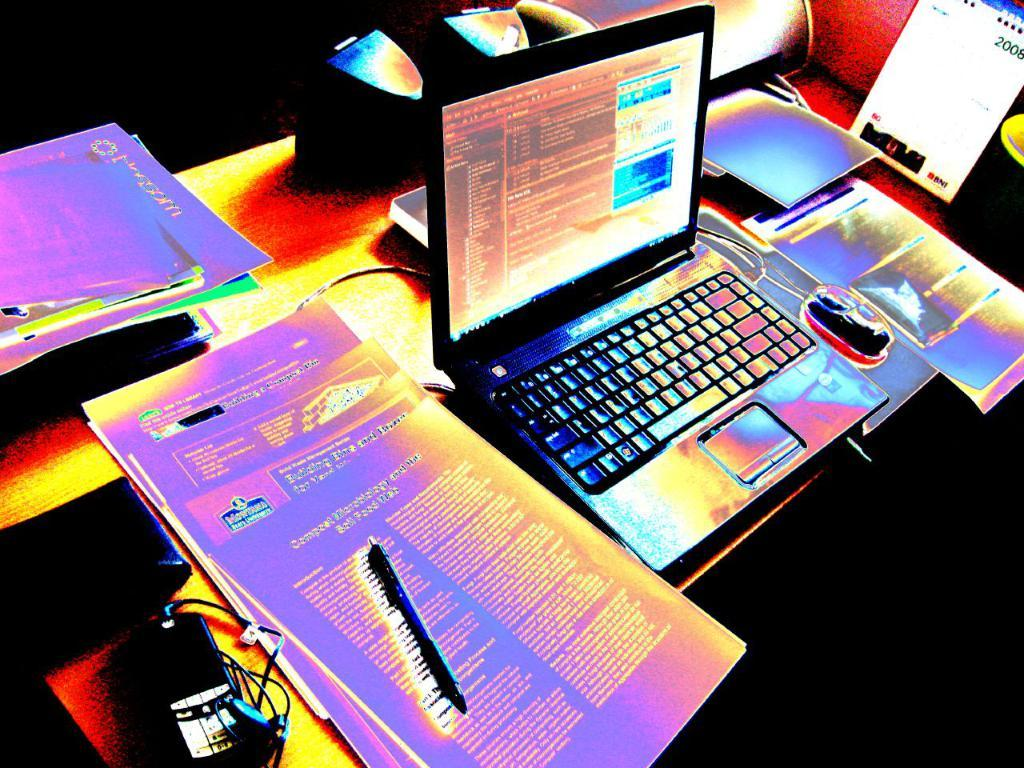Provide a one-sentence caption for the provided image. A table with paperwork and a laptop with a phone screen reading 2008 standing beside the computer mouse. 